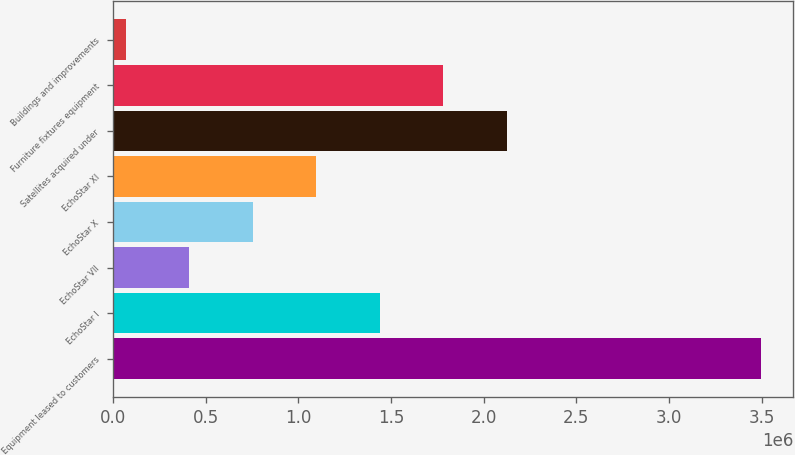<chart> <loc_0><loc_0><loc_500><loc_500><bar_chart><fcel>Equipment leased to customers<fcel>EchoStar I<fcel>EchoStar VII<fcel>EchoStar X<fcel>EchoStar XI<fcel>Satellites acquired under<fcel>Furniture fixtures equipment<fcel>Buildings and improvements<nl><fcel>3.49536e+06<fcel>1.44043e+06<fcel>412960<fcel>755449<fcel>1.09794e+06<fcel>2.1254e+06<fcel>1.78292e+06<fcel>70471<nl></chart> 